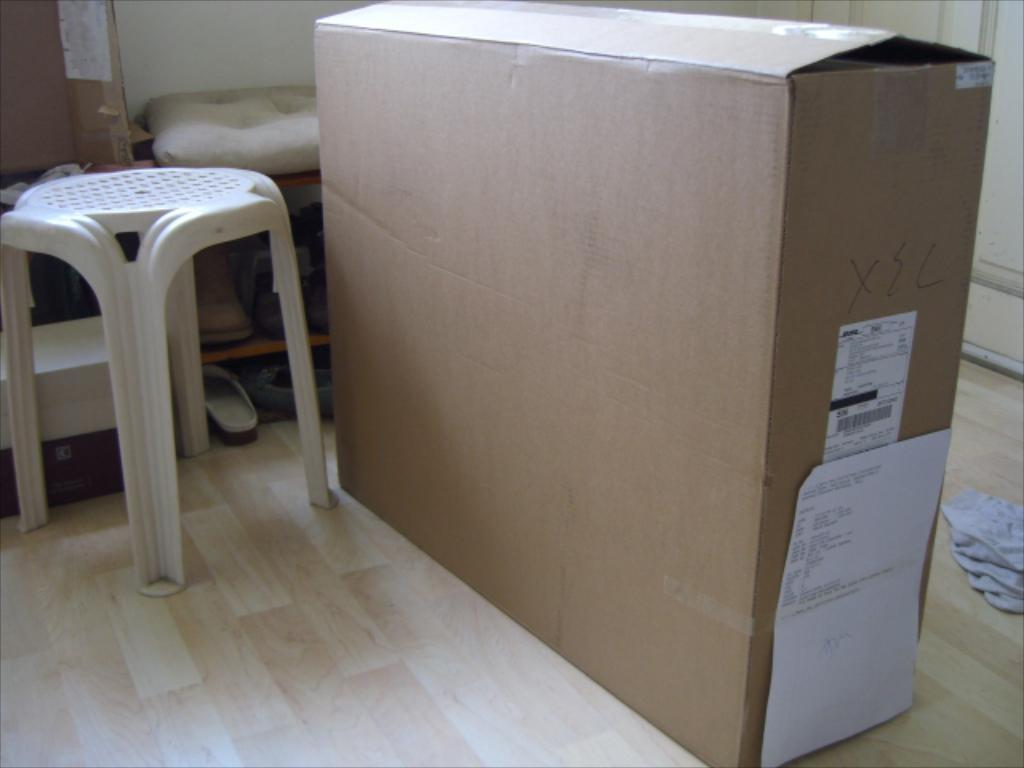What is one of the objects in the image? There is a cardboard box in the image. What type of furniture is present in the image? There is a chair in the image. What type of footwear is placed on a stand in the image? There are slippers in a stand in the image. What is placed on the stand along with the slippers? There are objects placed on the stand in the image. What feature of a room can be seen in the image? There is a door in the image. How many brothers are depicted in the image? There are no brothers present in the image. What type of fruit is placed on the stand with the slippers? There is no fruit, specifically oranges, present in the image. 